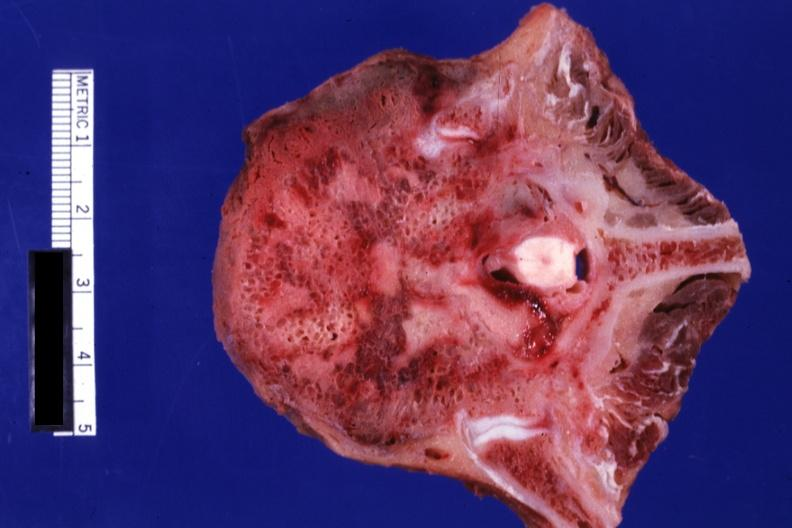what is present?
Answer the question using a single word or phrase. Joints 